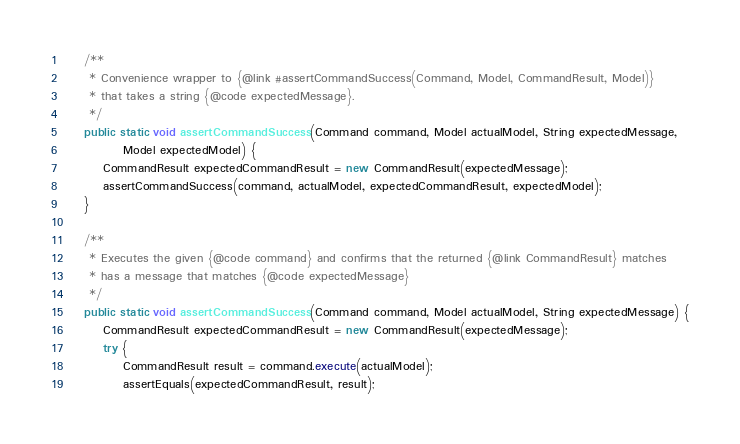<code> <loc_0><loc_0><loc_500><loc_500><_Java_>
    /**
     * Convenience wrapper to {@link #assertCommandSuccess(Command, Model, CommandResult, Model)}
     * that takes a string {@code expectedMessage}.
     */
    public static void assertCommandSuccess(Command command, Model actualModel, String expectedMessage,
            Model expectedModel) {
        CommandResult expectedCommandResult = new CommandResult(expectedMessage);
        assertCommandSuccess(command, actualModel, expectedCommandResult, expectedModel);
    }

    /**
     * Executes the given {@code command} and confirms that the returned {@link CommandResult} matches
     * has a message that matches {@code expectedMessage}
     */
    public static void assertCommandSuccess(Command command, Model actualModel, String expectedMessage) {
        CommandResult expectedCommandResult = new CommandResult(expectedMessage);
        try {
            CommandResult result = command.execute(actualModel);
            assertEquals(expectedCommandResult, result);</code> 